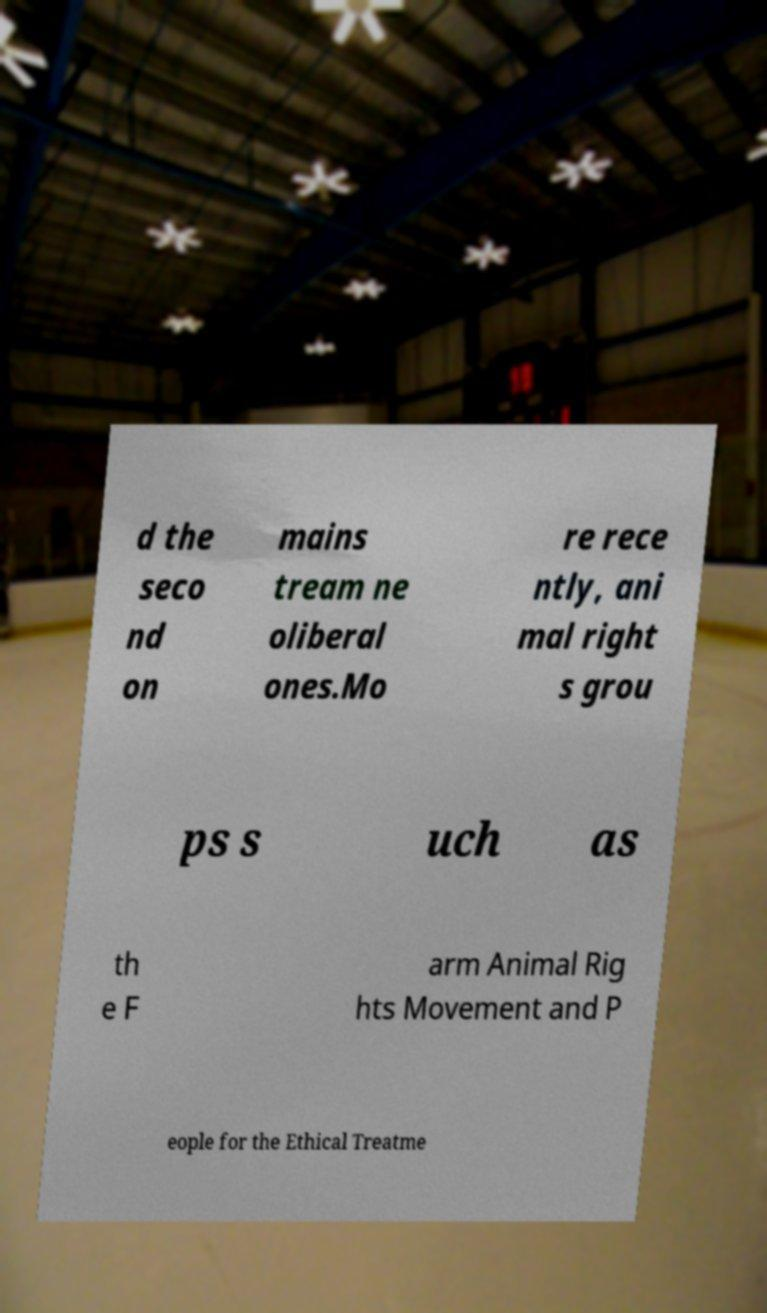Could you extract and type out the text from this image? d the seco nd on mains tream ne oliberal ones.Mo re rece ntly, ani mal right s grou ps s uch as th e F arm Animal Rig hts Movement and P eople for the Ethical Treatme 